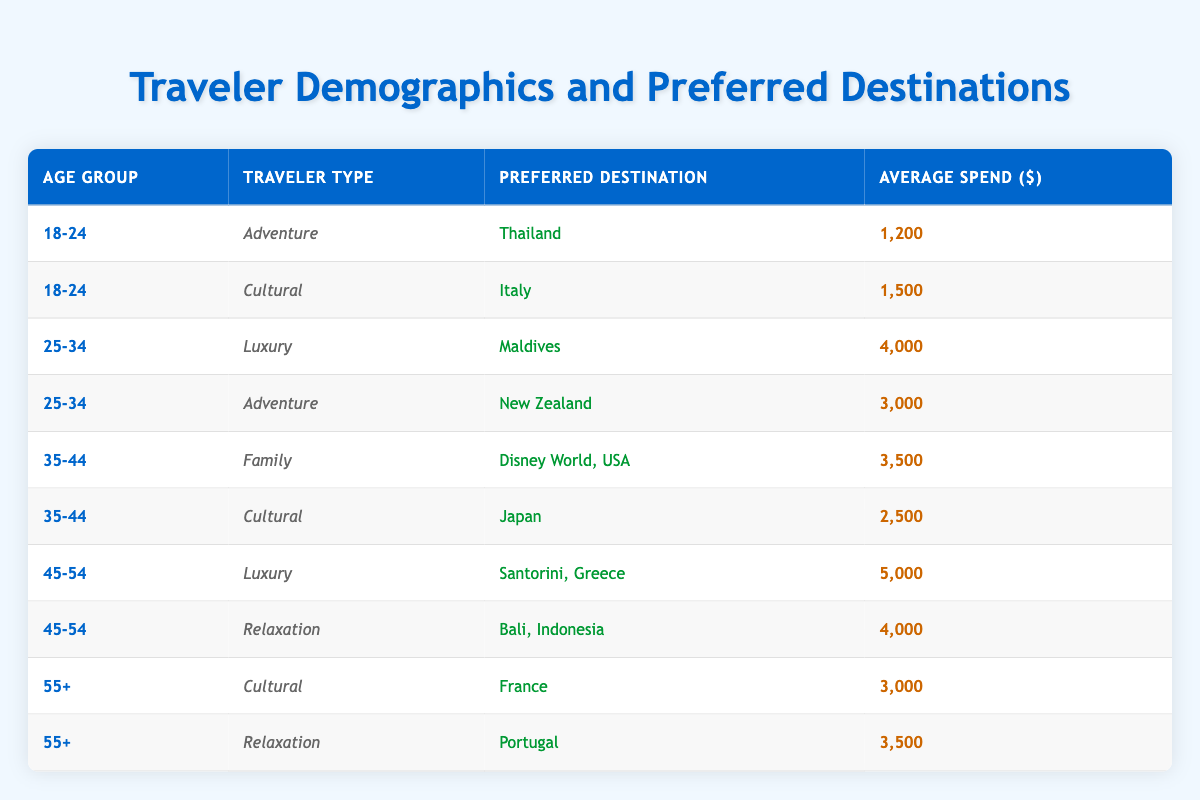What is the average spend for travelers in the age group 25-34? In the age group 25-34, there are two entries: Luxury travel to the Maldives with an average spend of 4000 and Adventure travel to New Zealand with an average spend of 3000. To find the average, we add 4000 and 3000 which gives us 7000, and then divide by 2 (the number of entries), resulting in an average of 3500.
Answer: 3500 Which age group shows the highest average spend? We need to calculate the average spend for each age group by summing their respective averages: For 18-24: (1200 + 1500) / 2 = 1350, for 25-34: (4000 + 3000) / 2 = 3500, for 35-44: (3500 + 2500) / 2 = 3000, for 45-54: (5000 + 4000) / 2 = 4500, for 55+: (3000 + 3500) / 2 = 3250. The highest average is 4500 for the age group 45-54.
Answer: 45-54 Is Japan a preferred destination for Adventure travelers? By checking the appropriate sections in the table, we see several traveler types listed under various age groups. Japan is listed under the Cultural traveler type, not Adventure, leading us to conclude that it is not a preferred destination for Adventure travelers.
Answer: No What is the total average spend for Family travelers? There is only one entry for Family travelers in the age group 35-44, which is Disney World, USA, with an average spend of 3500. Since there are no other entries, the total average spend for Family travelers is simply 3500.
Answer: 3500 In which destination do 45-54 year-olds spend the most money? The table lists two destinations for the 45-54 age group: Santorini, Greece (5000) for Luxury travelers and Bali, Indonesia (4000) for Relaxation travelers. Comparing the two, Santorini has the highest spend of 5000.
Answer: Santorini, Greece How many different traveler types are associated with the age group 18-24? The table presents two traveler types for the age group 18-24: Adventure (Thailand) and Cultural (Italy). Since both are distinct, we find that there are a total of 2 different traveler types for this age group.
Answer: 2 Do travelers aged 55+ prefer Cultural experiences more than Relaxation? In the 55+ age group, there are two entries: Cultural (France) with a spend of 3000 and Relaxation (Portugal) with a spend of 3500. Since the relaxation destination has a higher average spend, we can conclude that Relaxation is preferred over Cultural experiences among this age group.
Answer: No What is the combined average spend of all Luxury travelers? There are two luxury entries: one for 25-34 age group with a spend of 4000 (Maldives) and one for 45-54 age group with a spend of 5000 (Santorini). To find the combined average, we add 4000 and 5000 to get 9000, then divide by 2, which results in an average spend of 4500.
Answer: 4500 